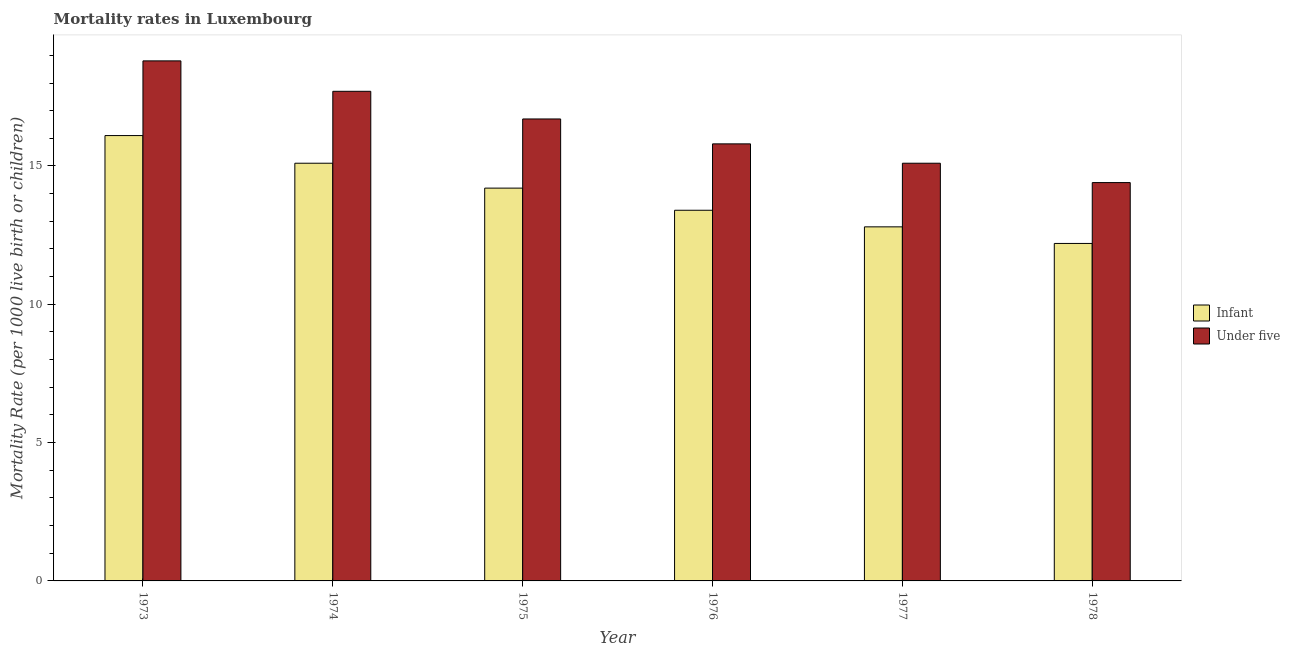How many different coloured bars are there?
Offer a very short reply. 2. How many groups of bars are there?
Make the answer very short. 6. What is the label of the 2nd group of bars from the left?
Ensure brevity in your answer.  1974. Across all years, what is the minimum under-5 mortality rate?
Ensure brevity in your answer.  14.4. In which year was the under-5 mortality rate maximum?
Provide a short and direct response. 1973. In which year was the infant mortality rate minimum?
Make the answer very short. 1978. What is the total infant mortality rate in the graph?
Give a very brief answer. 83.8. What is the difference between the under-5 mortality rate in 1975 and the infant mortality rate in 1973?
Offer a very short reply. -2.1. What is the average under-5 mortality rate per year?
Provide a succinct answer. 16.42. What is the ratio of the under-5 mortality rate in 1975 to that in 1978?
Provide a short and direct response. 1.16. Is the under-5 mortality rate in 1976 less than that in 1977?
Provide a succinct answer. No. What is the difference between the highest and the second highest under-5 mortality rate?
Provide a short and direct response. 1.1. What does the 2nd bar from the left in 1976 represents?
Give a very brief answer. Under five. What does the 1st bar from the right in 1978 represents?
Offer a very short reply. Under five. How many bars are there?
Ensure brevity in your answer.  12. Are all the bars in the graph horizontal?
Offer a very short reply. No. What is the difference between two consecutive major ticks on the Y-axis?
Your answer should be compact. 5. Are the values on the major ticks of Y-axis written in scientific E-notation?
Offer a terse response. No. Does the graph contain grids?
Your answer should be very brief. No. How many legend labels are there?
Provide a succinct answer. 2. What is the title of the graph?
Keep it short and to the point. Mortality rates in Luxembourg. What is the label or title of the X-axis?
Offer a very short reply. Year. What is the label or title of the Y-axis?
Offer a terse response. Mortality Rate (per 1000 live birth or children). What is the Mortality Rate (per 1000 live birth or children) in Infant in 1973?
Your response must be concise. 16.1. What is the Mortality Rate (per 1000 live birth or children) of Infant in 1974?
Provide a succinct answer. 15.1. What is the Mortality Rate (per 1000 live birth or children) of Infant in 1975?
Your answer should be compact. 14.2. What is the Mortality Rate (per 1000 live birth or children) of Infant in 1976?
Keep it short and to the point. 13.4. What is the Mortality Rate (per 1000 live birth or children) of Under five in 1977?
Your response must be concise. 15.1. What is the Mortality Rate (per 1000 live birth or children) of Under five in 1978?
Provide a short and direct response. 14.4. Across all years, what is the minimum Mortality Rate (per 1000 live birth or children) of Infant?
Offer a terse response. 12.2. What is the total Mortality Rate (per 1000 live birth or children) in Infant in the graph?
Offer a very short reply. 83.8. What is the total Mortality Rate (per 1000 live birth or children) of Under five in the graph?
Your answer should be compact. 98.5. What is the difference between the Mortality Rate (per 1000 live birth or children) of Infant in 1973 and that in 1974?
Your answer should be compact. 1. What is the difference between the Mortality Rate (per 1000 live birth or children) of Under five in 1973 and that in 1975?
Ensure brevity in your answer.  2.1. What is the difference between the Mortality Rate (per 1000 live birth or children) in Under five in 1973 and that in 1976?
Provide a succinct answer. 3. What is the difference between the Mortality Rate (per 1000 live birth or children) in Infant in 1973 and that in 1977?
Ensure brevity in your answer.  3.3. What is the difference between the Mortality Rate (per 1000 live birth or children) of Infant in 1974 and that in 1975?
Your answer should be very brief. 0.9. What is the difference between the Mortality Rate (per 1000 live birth or children) of Under five in 1974 and that in 1975?
Offer a very short reply. 1. What is the difference between the Mortality Rate (per 1000 live birth or children) in Under five in 1974 and that in 1976?
Offer a very short reply. 1.9. What is the difference between the Mortality Rate (per 1000 live birth or children) of Infant in 1974 and that in 1978?
Your response must be concise. 2.9. What is the difference between the Mortality Rate (per 1000 live birth or children) in Under five in 1975 and that in 1976?
Your answer should be compact. 0.9. What is the difference between the Mortality Rate (per 1000 live birth or children) in Under five in 1975 and that in 1978?
Provide a short and direct response. 2.3. What is the difference between the Mortality Rate (per 1000 live birth or children) in Under five in 1976 and that in 1978?
Offer a terse response. 1.4. What is the difference between the Mortality Rate (per 1000 live birth or children) of Infant in 1977 and that in 1978?
Keep it short and to the point. 0.6. What is the difference between the Mortality Rate (per 1000 live birth or children) in Under five in 1977 and that in 1978?
Your response must be concise. 0.7. What is the difference between the Mortality Rate (per 1000 live birth or children) of Infant in 1973 and the Mortality Rate (per 1000 live birth or children) of Under five in 1976?
Offer a very short reply. 0.3. What is the difference between the Mortality Rate (per 1000 live birth or children) of Infant in 1973 and the Mortality Rate (per 1000 live birth or children) of Under five in 1978?
Offer a terse response. 1.7. What is the difference between the Mortality Rate (per 1000 live birth or children) in Infant in 1974 and the Mortality Rate (per 1000 live birth or children) in Under five in 1975?
Make the answer very short. -1.6. What is the difference between the Mortality Rate (per 1000 live birth or children) in Infant in 1974 and the Mortality Rate (per 1000 live birth or children) in Under five in 1978?
Keep it short and to the point. 0.7. What is the difference between the Mortality Rate (per 1000 live birth or children) of Infant in 1975 and the Mortality Rate (per 1000 live birth or children) of Under five in 1977?
Give a very brief answer. -0.9. What is the difference between the Mortality Rate (per 1000 live birth or children) in Infant in 1975 and the Mortality Rate (per 1000 live birth or children) in Under five in 1978?
Ensure brevity in your answer.  -0.2. What is the average Mortality Rate (per 1000 live birth or children) of Infant per year?
Keep it short and to the point. 13.97. What is the average Mortality Rate (per 1000 live birth or children) of Under five per year?
Provide a succinct answer. 16.42. In the year 1973, what is the difference between the Mortality Rate (per 1000 live birth or children) in Infant and Mortality Rate (per 1000 live birth or children) in Under five?
Make the answer very short. -2.7. In the year 1975, what is the difference between the Mortality Rate (per 1000 live birth or children) of Infant and Mortality Rate (per 1000 live birth or children) of Under five?
Keep it short and to the point. -2.5. In the year 1976, what is the difference between the Mortality Rate (per 1000 live birth or children) in Infant and Mortality Rate (per 1000 live birth or children) in Under five?
Make the answer very short. -2.4. In the year 1978, what is the difference between the Mortality Rate (per 1000 live birth or children) in Infant and Mortality Rate (per 1000 live birth or children) in Under five?
Provide a short and direct response. -2.2. What is the ratio of the Mortality Rate (per 1000 live birth or children) of Infant in 1973 to that in 1974?
Offer a very short reply. 1.07. What is the ratio of the Mortality Rate (per 1000 live birth or children) of Under five in 1973 to that in 1974?
Offer a terse response. 1.06. What is the ratio of the Mortality Rate (per 1000 live birth or children) in Infant in 1973 to that in 1975?
Ensure brevity in your answer.  1.13. What is the ratio of the Mortality Rate (per 1000 live birth or children) of Under five in 1973 to that in 1975?
Give a very brief answer. 1.13. What is the ratio of the Mortality Rate (per 1000 live birth or children) in Infant in 1973 to that in 1976?
Make the answer very short. 1.2. What is the ratio of the Mortality Rate (per 1000 live birth or children) of Under five in 1973 to that in 1976?
Keep it short and to the point. 1.19. What is the ratio of the Mortality Rate (per 1000 live birth or children) in Infant in 1973 to that in 1977?
Provide a succinct answer. 1.26. What is the ratio of the Mortality Rate (per 1000 live birth or children) of Under five in 1973 to that in 1977?
Your answer should be compact. 1.25. What is the ratio of the Mortality Rate (per 1000 live birth or children) in Infant in 1973 to that in 1978?
Offer a very short reply. 1.32. What is the ratio of the Mortality Rate (per 1000 live birth or children) in Under five in 1973 to that in 1978?
Give a very brief answer. 1.31. What is the ratio of the Mortality Rate (per 1000 live birth or children) in Infant in 1974 to that in 1975?
Ensure brevity in your answer.  1.06. What is the ratio of the Mortality Rate (per 1000 live birth or children) of Under five in 1974 to that in 1975?
Keep it short and to the point. 1.06. What is the ratio of the Mortality Rate (per 1000 live birth or children) in Infant in 1974 to that in 1976?
Ensure brevity in your answer.  1.13. What is the ratio of the Mortality Rate (per 1000 live birth or children) in Under five in 1974 to that in 1976?
Your answer should be very brief. 1.12. What is the ratio of the Mortality Rate (per 1000 live birth or children) of Infant in 1974 to that in 1977?
Provide a short and direct response. 1.18. What is the ratio of the Mortality Rate (per 1000 live birth or children) in Under five in 1974 to that in 1977?
Give a very brief answer. 1.17. What is the ratio of the Mortality Rate (per 1000 live birth or children) in Infant in 1974 to that in 1978?
Make the answer very short. 1.24. What is the ratio of the Mortality Rate (per 1000 live birth or children) in Under five in 1974 to that in 1978?
Your answer should be compact. 1.23. What is the ratio of the Mortality Rate (per 1000 live birth or children) in Infant in 1975 to that in 1976?
Ensure brevity in your answer.  1.06. What is the ratio of the Mortality Rate (per 1000 live birth or children) of Under five in 1975 to that in 1976?
Provide a succinct answer. 1.06. What is the ratio of the Mortality Rate (per 1000 live birth or children) of Infant in 1975 to that in 1977?
Give a very brief answer. 1.11. What is the ratio of the Mortality Rate (per 1000 live birth or children) of Under five in 1975 to that in 1977?
Make the answer very short. 1.11. What is the ratio of the Mortality Rate (per 1000 live birth or children) of Infant in 1975 to that in 1978?
Provide a succinct answer. 1.16. What is the ratio of the Mortality Rate (per 1000 live birth or children) in Under five in 1975 to that in 1978?
Your response must be concise. 1.16. What is the ratio of the Mortality Rate (per 1000 live birth or children) in Infant in 1976 to that in 1977?
Keep it short and to the point. 1.05. What is the ratio of the Mortality Rate (per 1000 live birth or children) of Under five in 1976 to that in 1977?
Provide a succinct answer. 1.05. What is the ratio of the Mortality Rate (per 1000 live birth or children) in Infant in 1976 to that in 1978?
Offer a very short reply. 1.1. What is the ratio of the Mortality Rate (per 1000 live birth or children) of Under five in 1976 to that in 1978?
Your answer should be very brief. 1.1. What is the ratio of the Mortality Rate (per 1000 live birth or children) in Infant in 1977 to that in 1978?
Keep it short and to the point. 1.05. What is the ratio of the Mortality Rate (per 1000 live birth or children) of Under five in 1977 to that in 1978?
Give a very brief answer. 1.05. What is the difference between the highest and the second highest Mortality Rate (per 1000 live birth or children) in Under five?
Give a very brief answer. 1.1. 